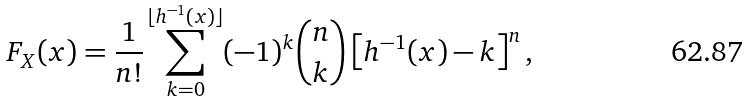Convert formula to latex. <formula><loc_0><loc_0><loc_500><loc_500>F _ { X } ( x ) = \frac { 1 } { n ! } \sum _ { k = 0 } ^ { \lfloor h ^ { - 1 } ( x ) \rfloor } ( - 1 ) ^ { k } { n \choose k } \left [ h ^ { - 1 } ( x ) - k \right ] ^ { n } ,</formula> 